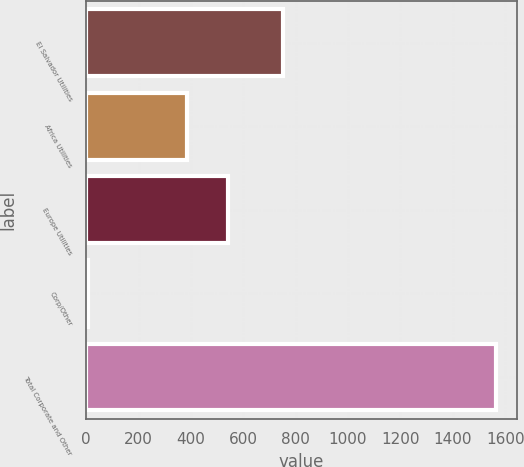Convert chart to OTSL. <chart><loc_0><loc_0><loc_500><loc_500><bar_chart><fcel>El Salvador Utilities<fcel>Africa Utilities<fcel>Europe Utilities<fcel>Corp/Other<fcel>Total Corporate and Other<nl><fcel>753<fcel>386<fcel>541.7<fcel>8<fcel>1565<nl></chart> 